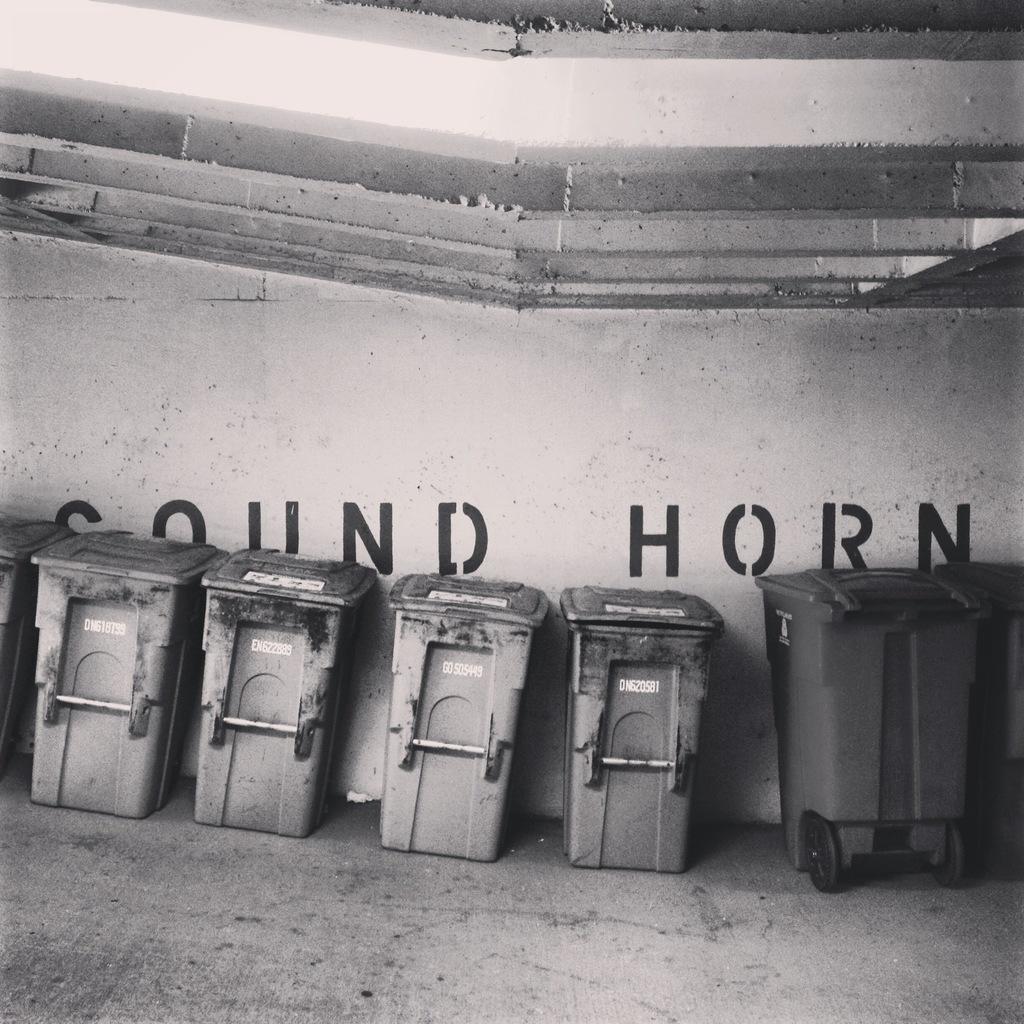What does the wall read?
Ensure brevity in your answer.  Sound horn. What does this wall tell you to sound?
Give a very brief answer. Horn. 